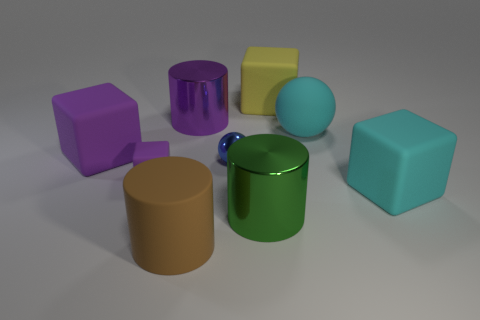Which objects have reflective surfaces? Upon inspecting the image, the green cylinder and the purple cube have reflective surfaces that mirror their surroundings, indicating they possess a more glossy finish compared to the other objects. 